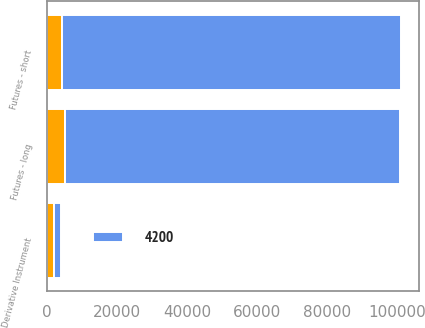Convert chart to OTSL. <chart><loc_0><loc_0><loc_500><loc_500><stacked_bar_chart><ecel><fcel>Derivative Instrument<fcel>Futures - long<fcel>Futures - short<nl><fcel>4200<fcel>2015<fcel>95709<fcel>96897<nl><fcel>nan<fcel>2016<fcel>5116<fcel>4341<nl></chart> 